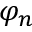Convert formula to latex. <formula><loc_0><loc_0><loc_500><loc_500>\varphi _ { n }</formula> 